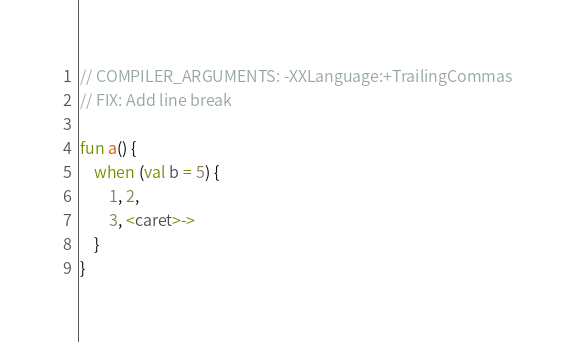<code> <loc_0><loc_0><loc_500><loc_500><_Kotlin_>// COMPILER_ARGUMENTS: -XXLanguage:+TrailingCommas
// FIX: Add line break

fun a() {
    when (val b = 5) {
        1, 2,
        3, <caret>->
    }
}</code> 